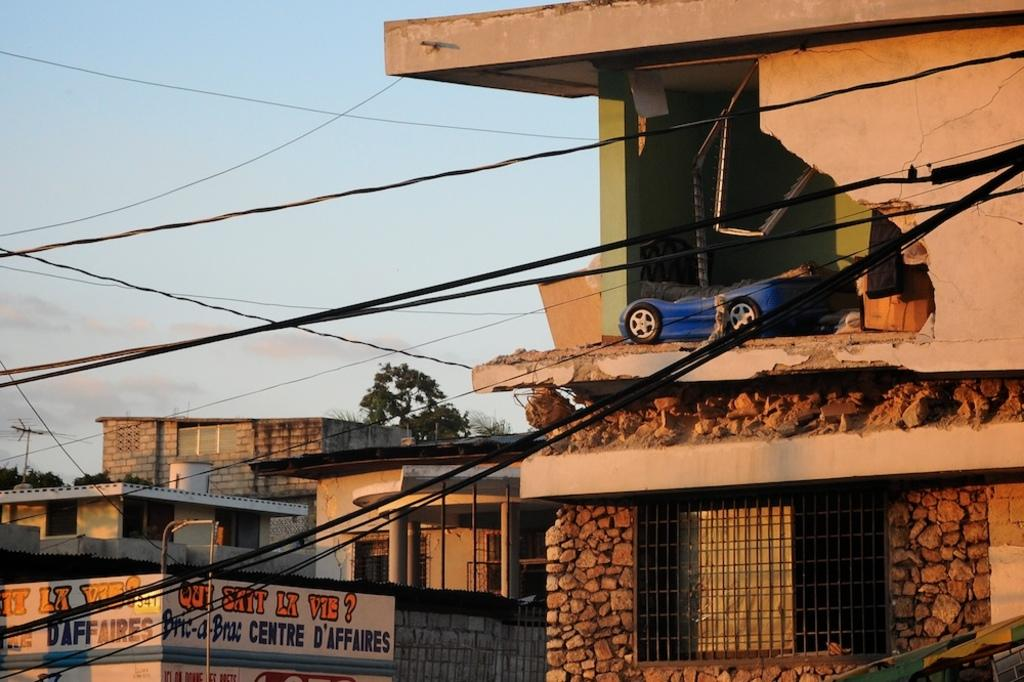What is the condition of the wall in the image? There is a crumbled wall in the image. What type of object can be seen near the wall? There is a toy car in the image. What structures are visible in the image? There are buildings in the image. What are the cables used for in the image? The purpose of the cables is not specified in the image, but they are visible. What can be seen in the windows in the image? The contents of the windows are not visible in the image. What type of vegetation is present in the image? There are trees in the image. What is visible in the background of the image? The sky is visible in the image. What type of butter is being spread on the sand in the image? There is no butter or sand present in the image. What decision is being made by the toy car in the image? The toy car is an inanimate object and cannot make decisions. 